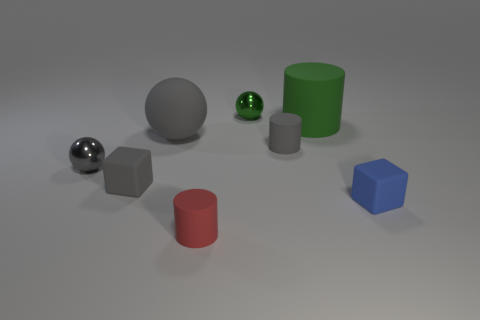There is a small shiny thing behind the metal object on the left side of the matte sphere in front of the large green rubber thing; what is its shape?
Provide a succinct answer. Sphere. Does the ball that is right of the rubber sphere have the same size as the matte cylinder on the right side of the tiny gray cylinder?
Provide a succinct answer. No. What number of red cylinders have the same material as the small red thing?
Keep it short and to the point. 0. There is a block right of the big green thing that is behind the tiny blue thing; how many small rubber objects are right of it?
Give a very brief answer. 0. Do the green metallic thing and the large gray object have the same shape?
Offer a terse response. Yes. Are there any small gray things that have the same shape as the tiny red rubber thing?
Your response must be concise. Yes. The red rubber thing that is the same size as the green metal ball is what shape?
Your answer should be compact. Cylinder. There is a small blue object on the right side of the rubber cylinder in front of the small cylinder behind the gray metallic thing; what is it made of?
Provide a short and direct response. Rubber. Do the green shiny thing and the green rubber cylinder have the same size?
Offer a terse response. No. What is the large ball made of?
Provide a short and direct response. Rubber. 